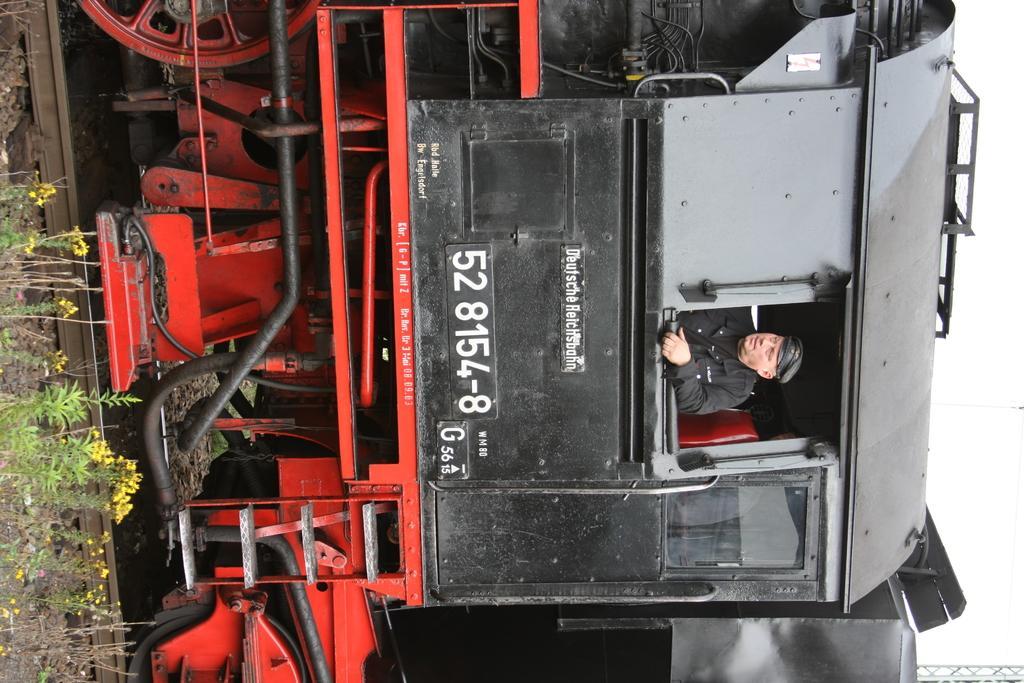How would you summarize this image in a sentence or two? In the middle of the picture we can see train on railway track. In the train we can see a person. On the left there are plants, flowers and stones. On the right it is sky. At the top we can see cables like objects. 